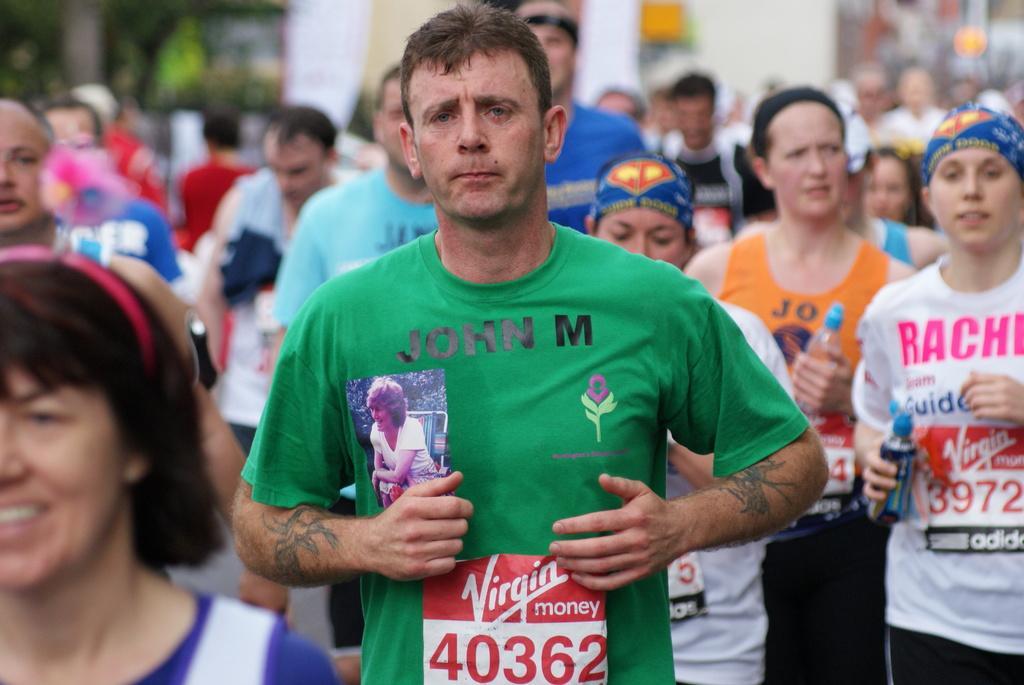Please provide a concise description of this image. In this picture there are many people jogging. The background is blurred. In the background there are buildings and trees. 